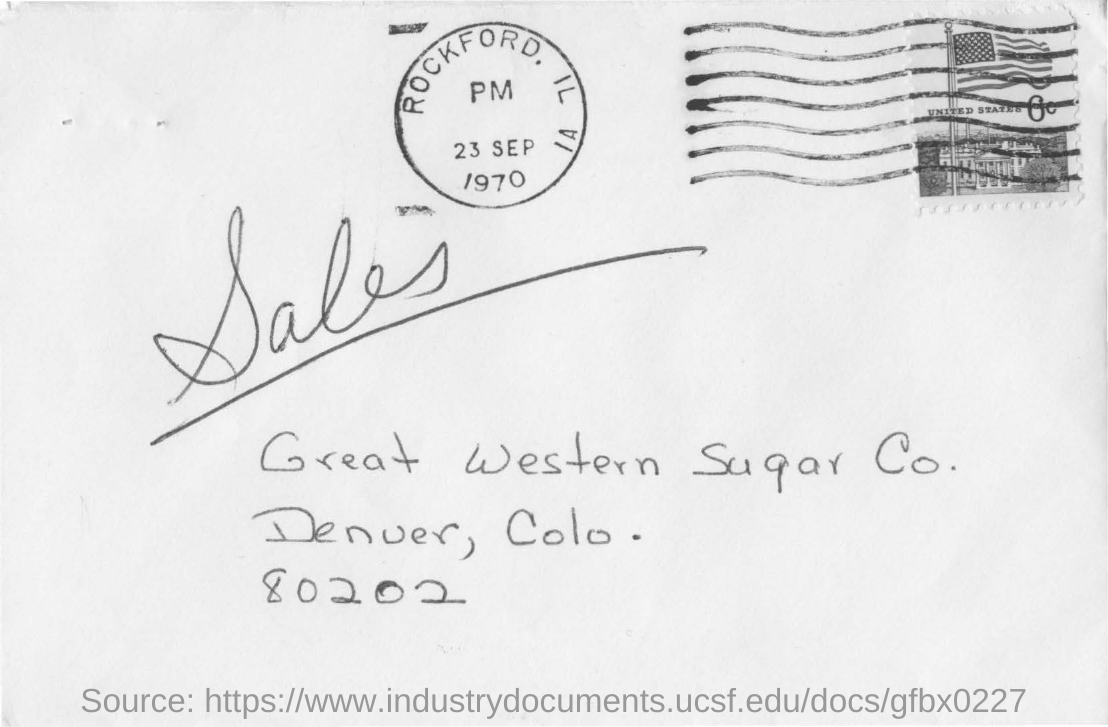Point out several critical features in this image. I request that the ZIP code 80202 be mentioned in the text. The date seen on the seal at the top of the letter is 23 September 1970. The Great Western Sugar Co. is located in Denver, Colorado. The address mentioned on the letter is that of Great Western Sugar Co... The place name "Rockford" is depicted on the seal. 